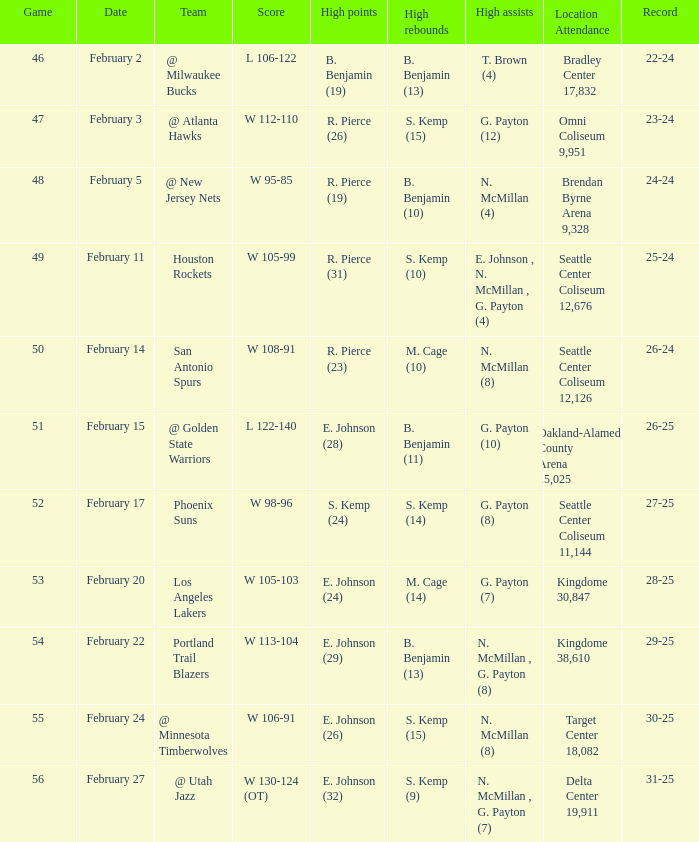Which game ended with a w 95-85 scoreline? 48.0. 